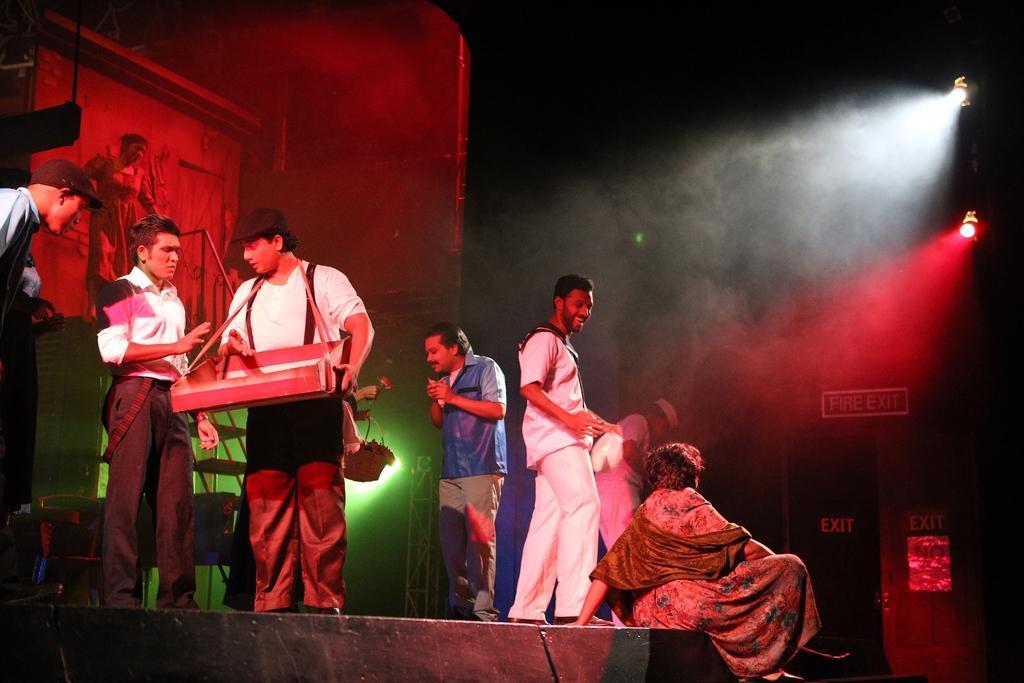Could you give a brief overview of what you see in this image? In the middle of the image few people are standing and holding some musical instruments. Behind them there is a screen. At the bottom of the image there is a stage and there is a sign board. 